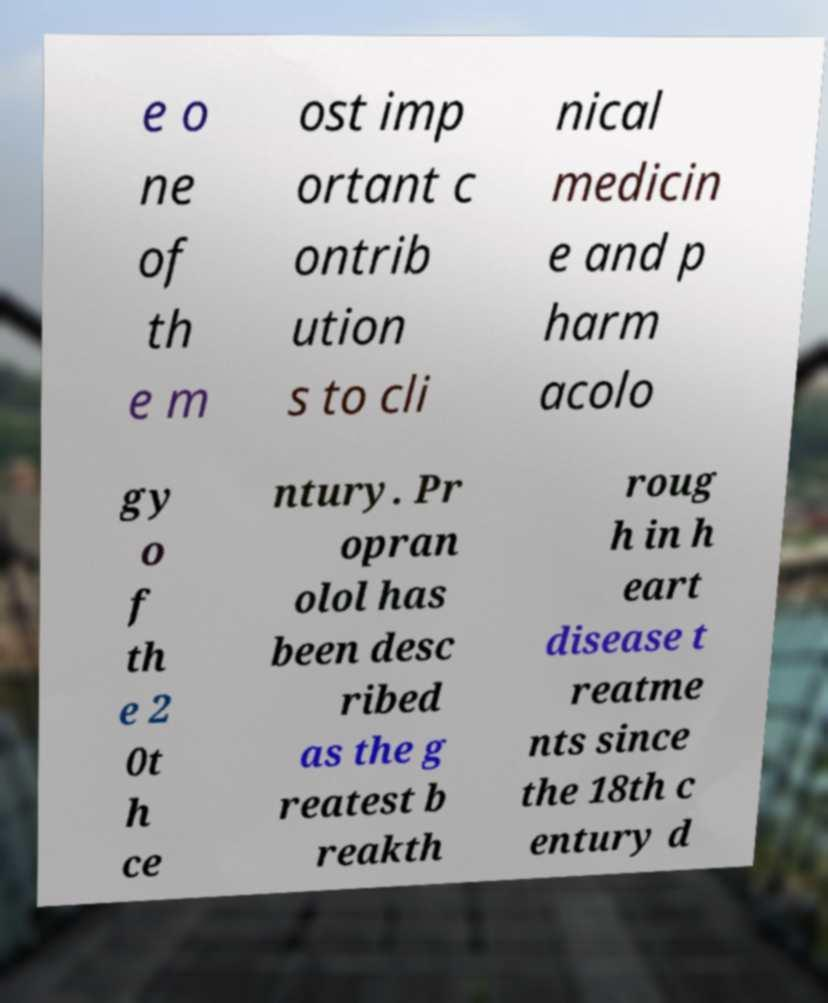For documentation purposes, I need the text within this image transcribed. Could you provide that? e o ne of th e m ost imp ortant c ontrib ution s to cli nical medicin e and p harm acolo gy o f th e 2 0t h ce ntury. Pr opran olol has been desc ribed as the g reatest b reakth roug h in h eart disease t reatme nts since the 18th c entury d 